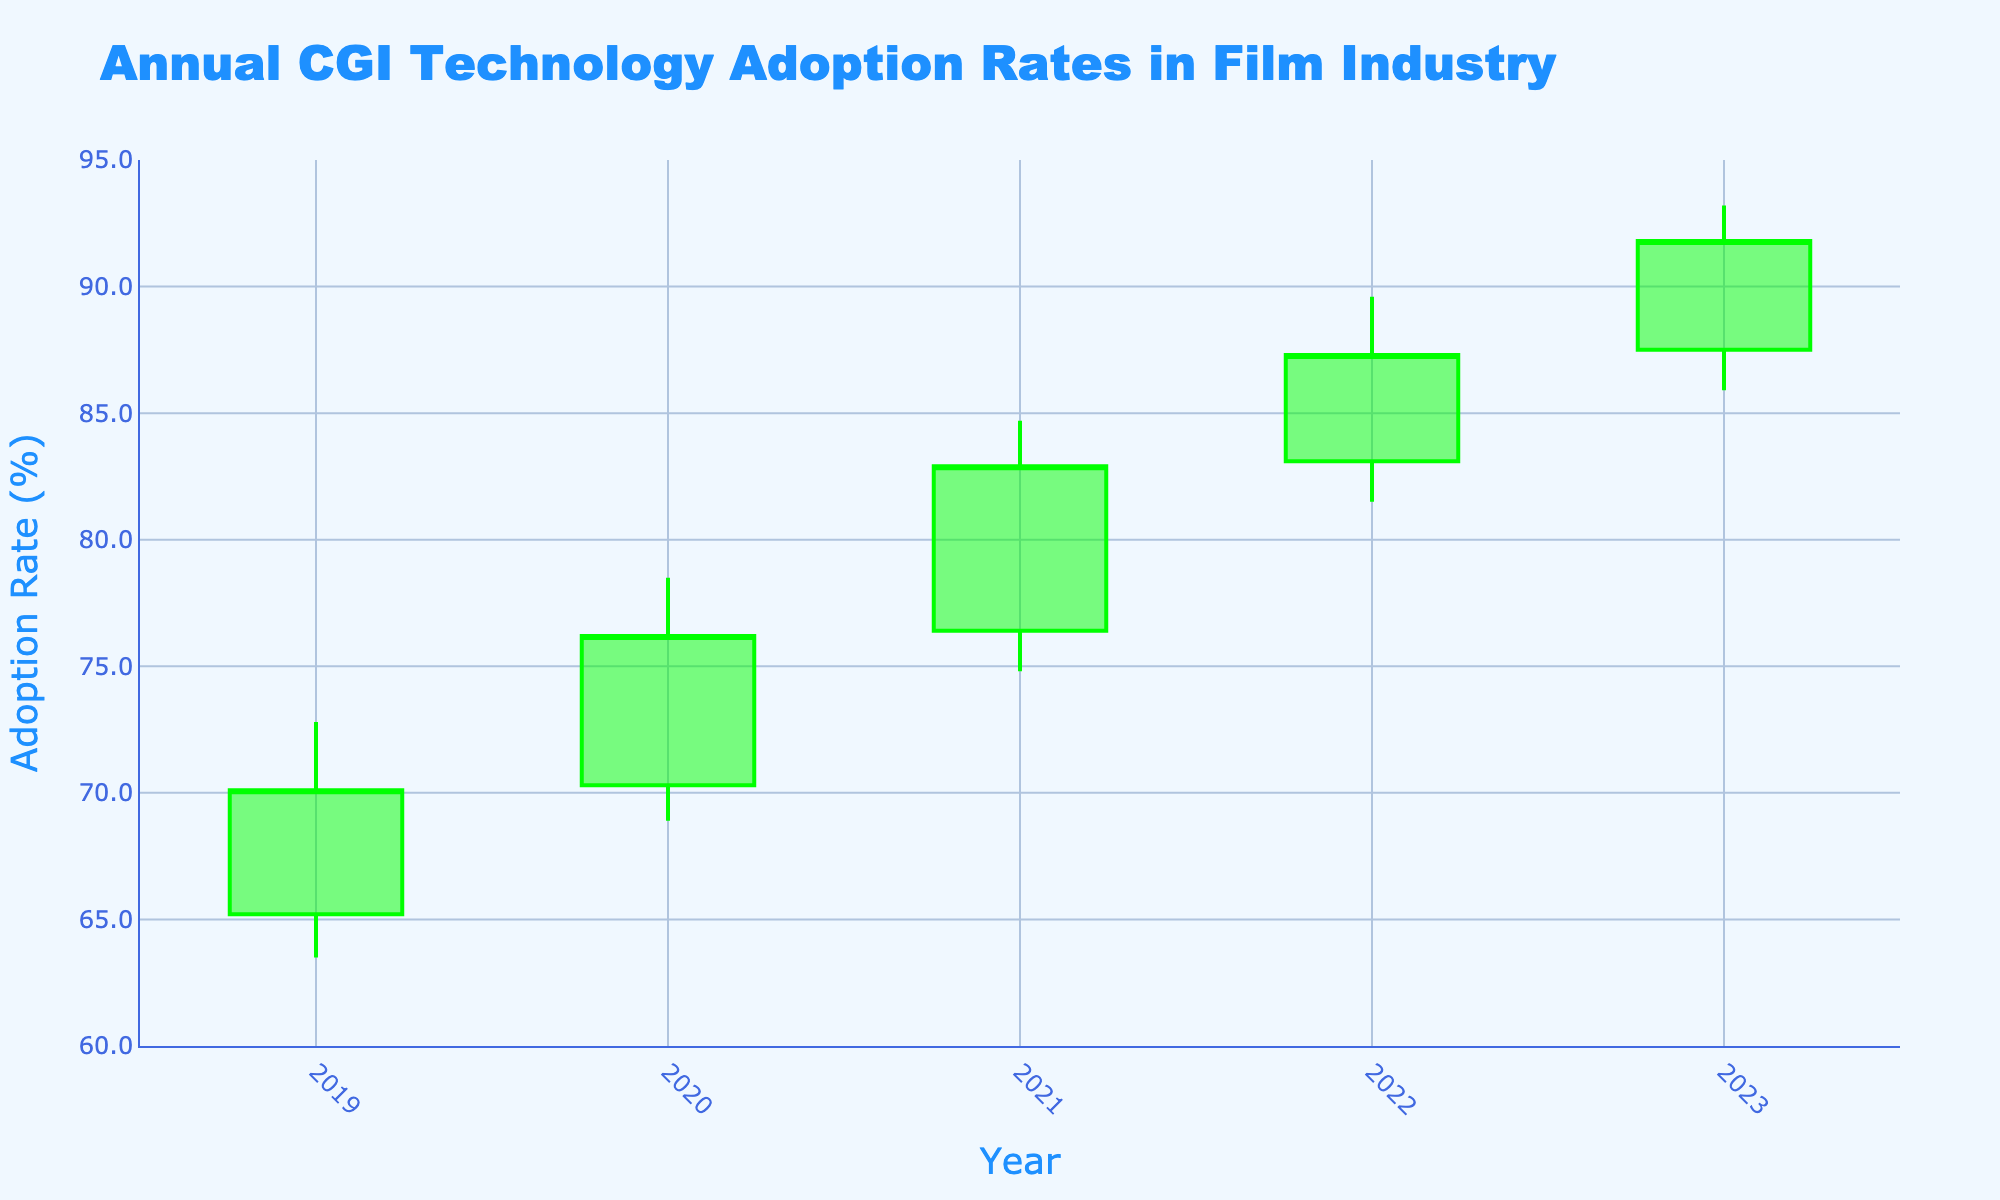What is the title of the chart? The title is written at the top of the chart and conveys the main topic or theme being depicted. In this case, it is reflected on the chart's title.
Answer: Annual CGI Technology Adoption Rates in Film Industry What is the y-axis title? The y-axis title is located next to the y-axis and indicates the metric being measured. In this chart, it shows the metric for the values plotted on the y-axis.
Answer: Adoption Rate (%) How many years of data are presented in the chart? The x-axis displays the years for which adoption rates are plotted. By counting these, we can determine the number of years.
Answer: 5 Which year had the highest “High” adoption rate? The 'High' rate represents the maximum adoption rate in each year. By identifying the largest 'High' value and corresponding year, we find the answer.
Answer: 2023 By how much did the final "Close" rate increase from 2019 to 2023? We need to subtract the "Close" rate of 2019 from the "Close" rate of 2023 to find the increase.
Answer: 21.7% How does the 2022 closing adoption rate compare to that of 2023? By looking at the "Close" rates for 2022 and 2023 and determining if 2022's rate is less than, greater than, or equal to 2023's rate, we can compare them.
Answer: 2022's rate is less than 2023's What is the general trend in CGI adoption rates from 2019 to 2023? By observing the "Open" and "Close" rates over each year, the overall trend can be interpreted.
Answer: Increasing Which year experienced the lowest "Low" adoption rate? The 'Low' rate represents the minimum adoption rate in each year. By identifying the smallest 'Low' value and its corresponding year, we find the answer.
Answer: 2019 What was the range of adoption rates in 2020? The range is calculated by subtracting the 'Low' rate from the 'High' rate for 2020.
Answer: 9.6% Which year showed the highest increase in the "Closing" rate from the previous year? By calculating the increase from one year's "Close" rate to the next for all consecutive years, we can identify the highest increase.
Answer: 2020 